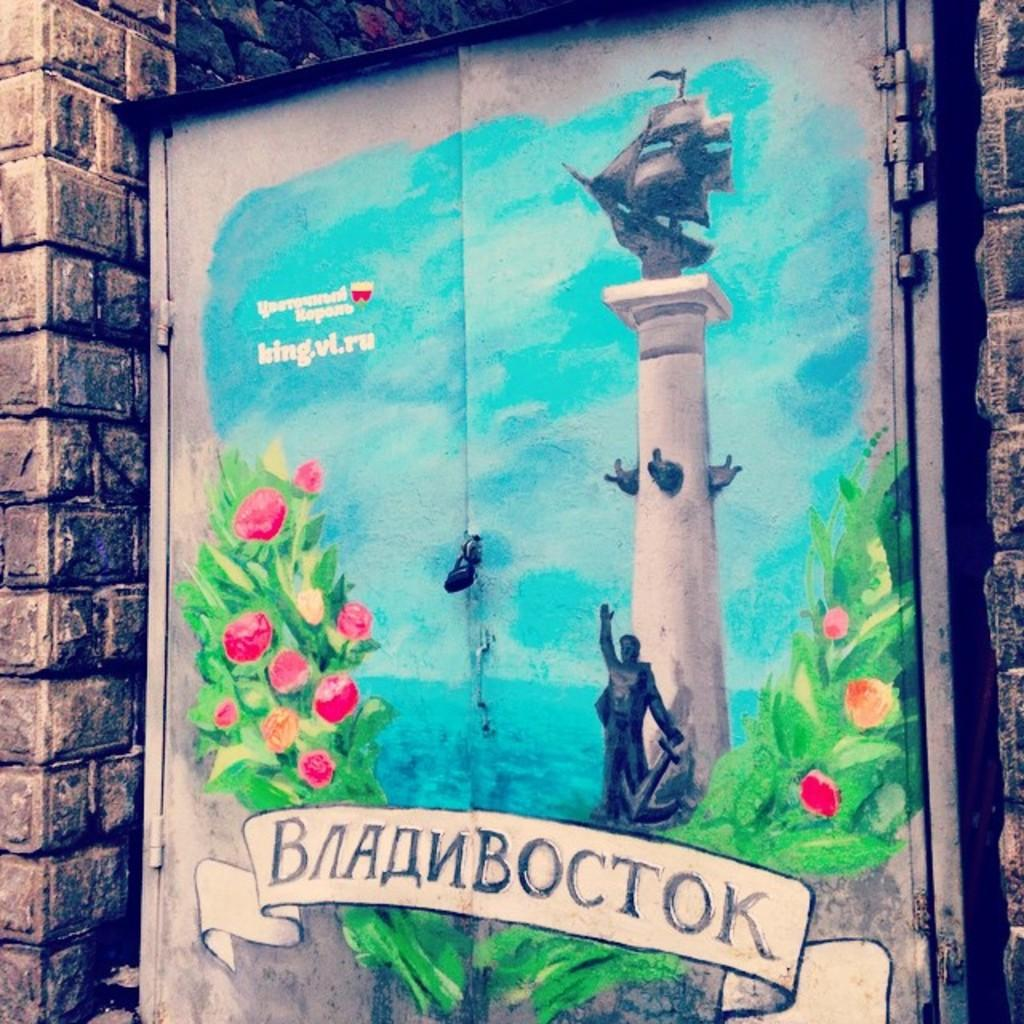What is depicted on the doors in the image? There is a painting on the doors in the image. What elements are included in the painting? The painting contains flowers, leaves, a statue, and a sky. Can you describe the background of the painting? The painting contains a brick wall visible in the background. What type of meat is being served on the door in the image? There is no meat present in the image; the main subject is a painting on the doors that contains flowers, leaves, a statue, and a sky. 